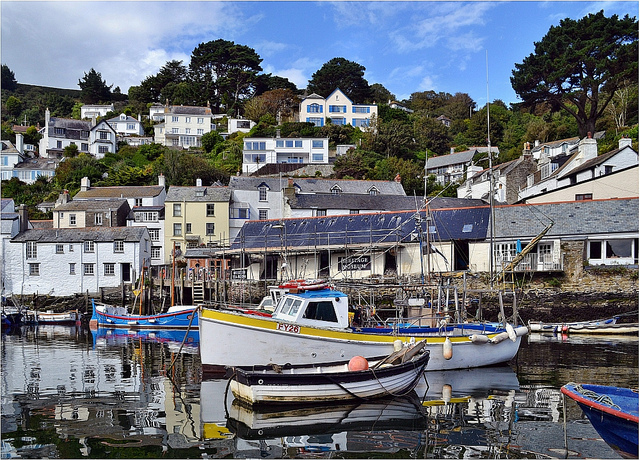Please extract the text content from this image. FY26 